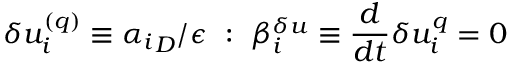Convert formula to latex. <formula><loc_0><loc_0><loc_500><loc_500>\delta u _ { i } ^ { ( q ) } \equiv \alpha _ { i } _ { D } / \epsilon \colon \beta _ { i } ^ { \delta u } \equiv \frac { d } { d t } \delta u _ { i } ^ { q } = 0</formula> 